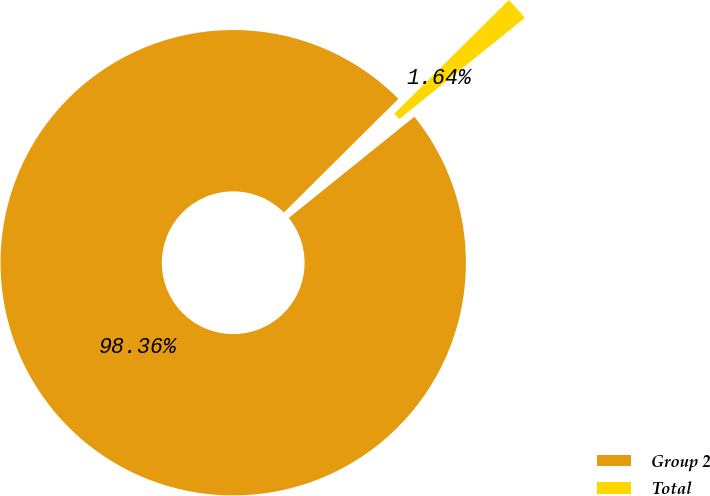Convert chart. <chart><loc_0><loc_0><loc_500><loc_500><pie_chart><fcel>Group 2<fcel>Total<nl><fcel>98.36%<fcel>1.64%<nl></chart> 